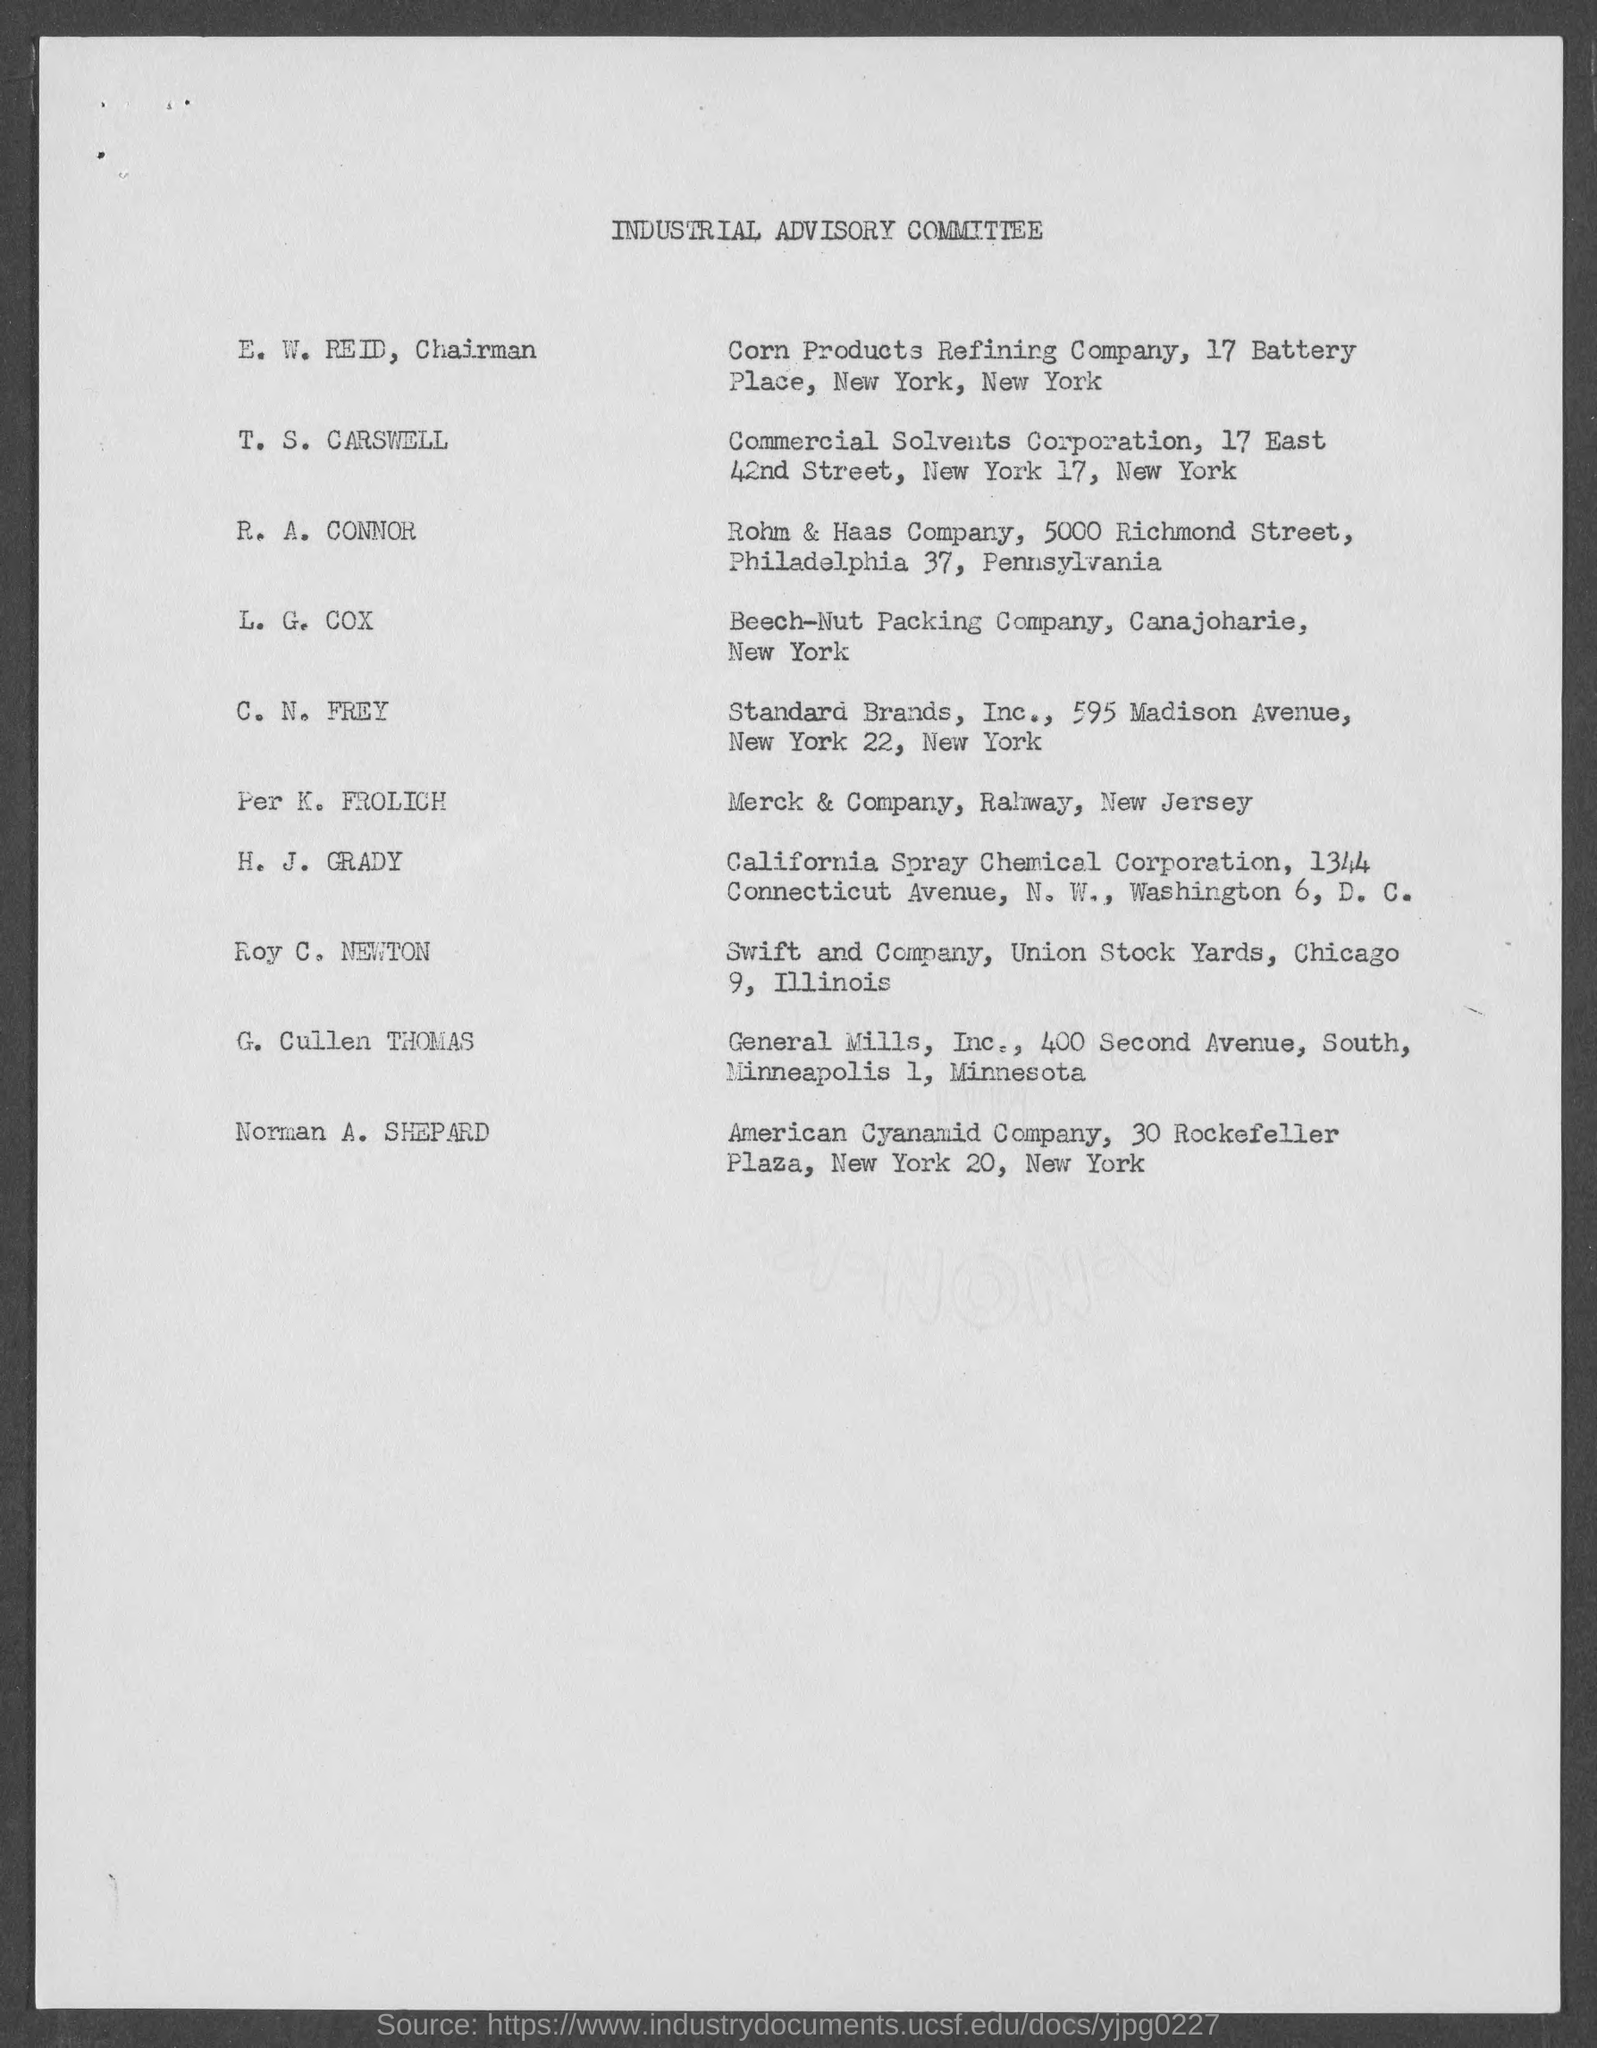Indicate a few pertinent items in this graphic. The Chairman is E. W. Reid. The document's title is 'Industrial Advisory Committee.' 